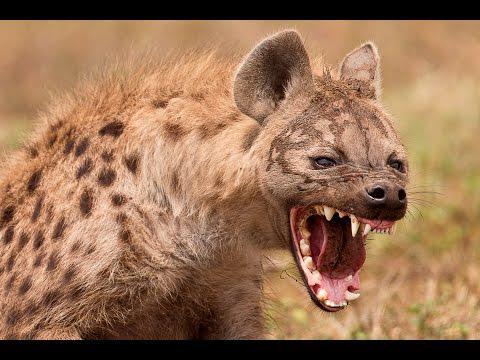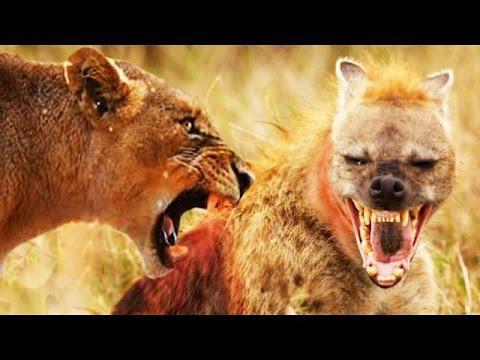The first image is the image on the left, the second image is the image on the right. Analyze the images presented: Is the assertion "The lefthand image includes a lion, and the righthand image contains only a fang-baring hyena." valid? Answer yes or no. No. The first image is the image on the left, the second image is the image on the right. Considering the images on both sides, is "The right image contains at least two animals." valid? Answer yes or no. Yes. 